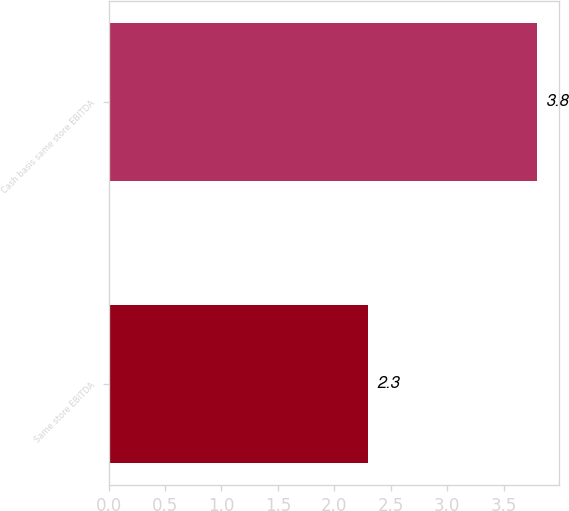Convert chart to OTSL. <chart><loc_0><loc_0><loc_500><loc_500><bar_chart><fcel>Same store EBITDA<fcel>Cash basis same store EBITDA<nl><fcel>2.3<fcel>3.8<nl></chart> 